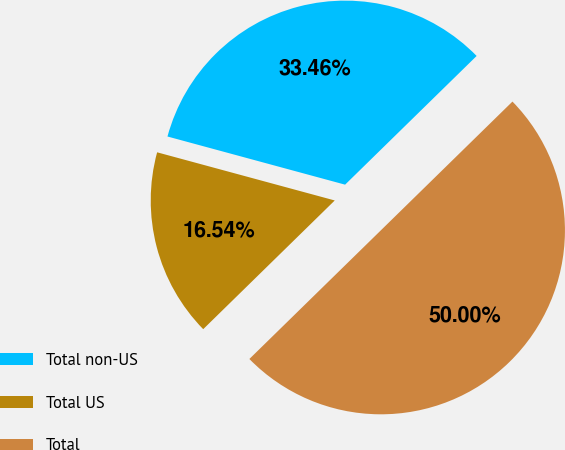Convert chart. <chart><loc_0><loc_0><loc_500><loc_500><pie_chart><fcel>Total non-US<fcel>Total US<fcel>Total<nl><fcel>33.46%<fcel>16.54%<fcel>50.0%<nl></chart> 